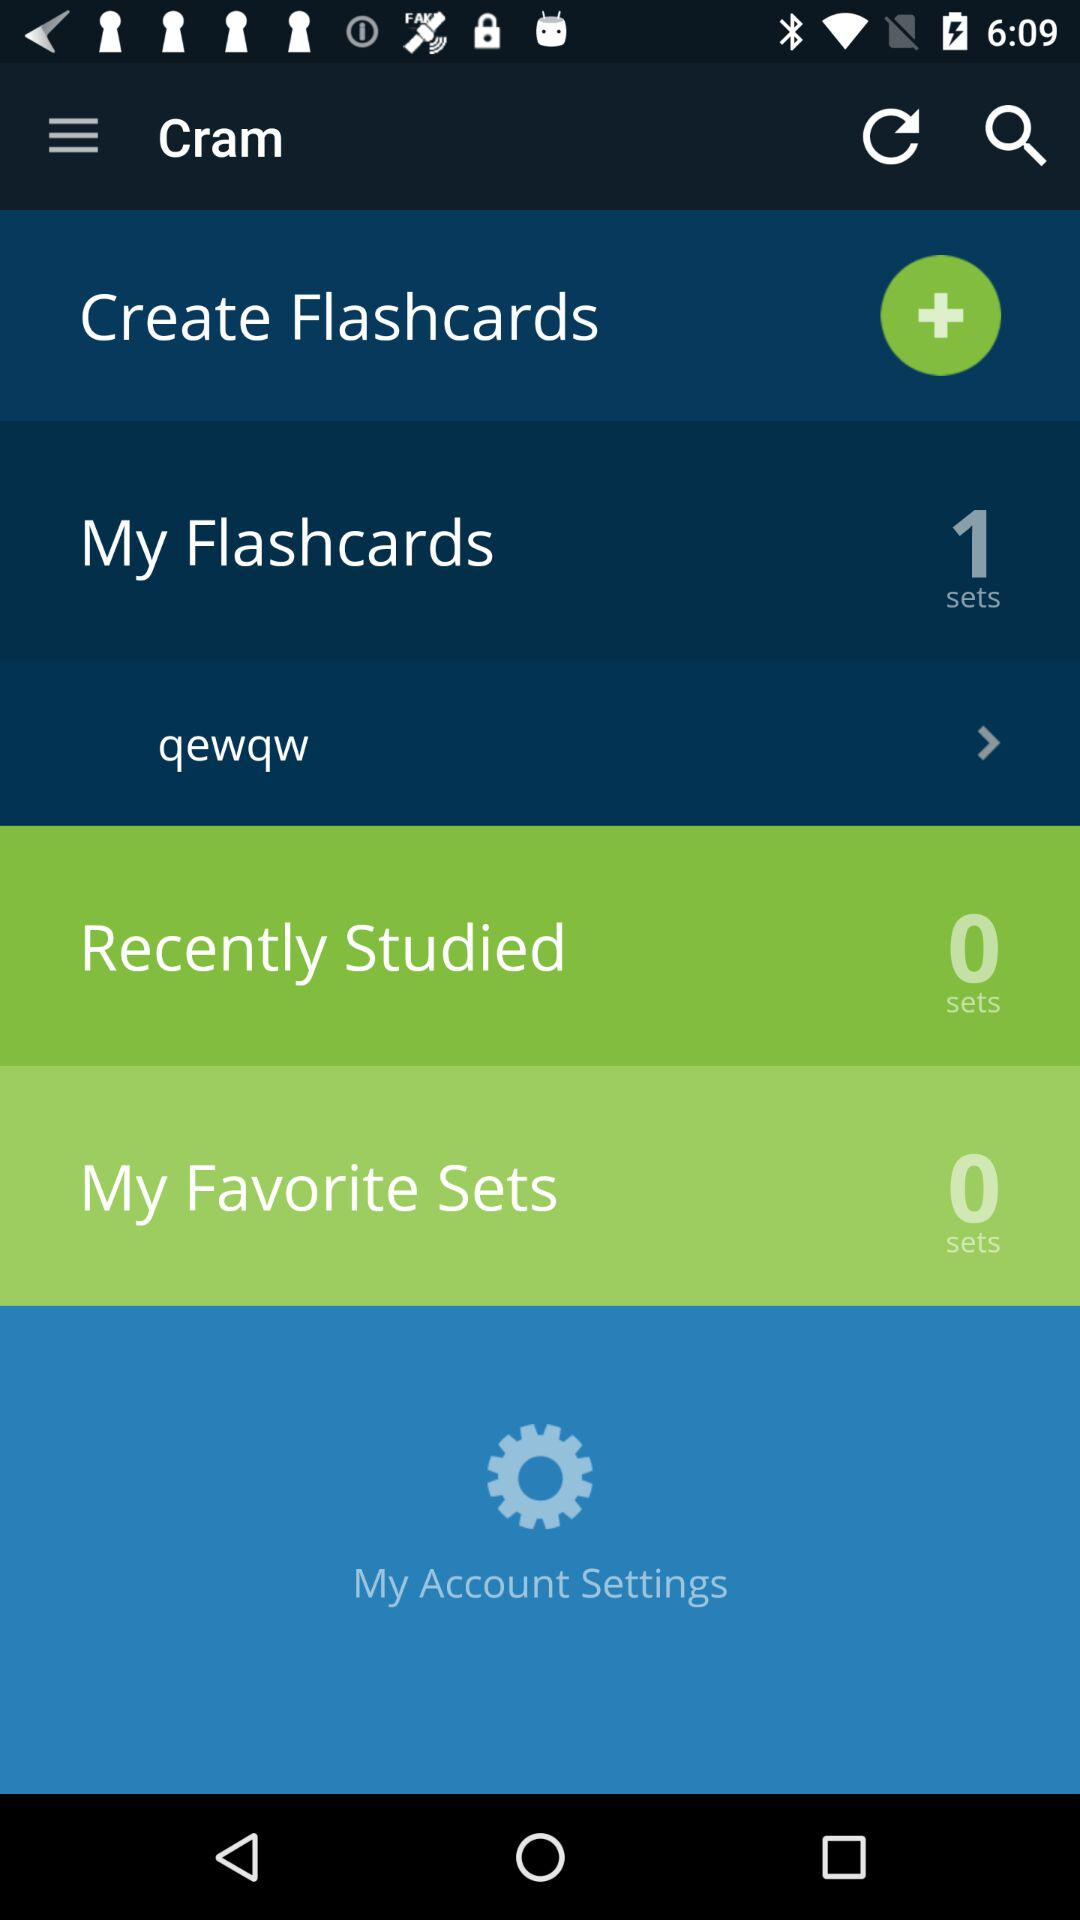How many flashcard sets are created? There is 1 flashcard set created. 